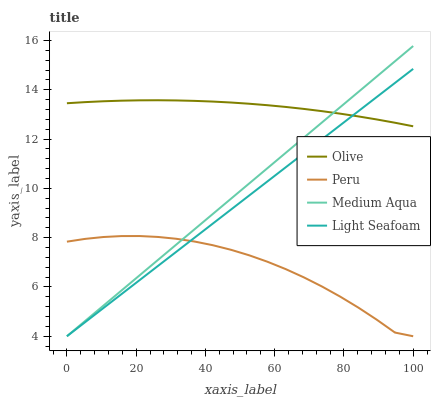Does Peru have the minimum area under the curve?
Answer yes or no. Yes. Does Olive have the maximum area under the curve?
Answer yes or no. Yes. Does Light Seafoam have the minimum area under the curve?
Answer yes or no. No. Does Light Seafoam have the maximum area under the curve?
Answer yes or no. No. Is Medium Aqua the smoothest?
Answer yes or no. Yes. Is Peru the roughest?
Answer yes or no. Yes. Is Light Seafoam the smoothest?
Answer yes or no. No. Is Light Seafoam the roughest?
Answer yes or no. No. Does Light Seafoam have the lowest value?
Answer yes or no. Yes. Does Medium Aqua have the highest value?
Answer yes or no. Yes. Does Light Seafoam have the highest value?
Answer yes or no. No. Is Peru less than Olive?
Answer yes or no. Yes. Is Olive greater than Peru?
Answer yes or no. Yes. Does Light Seafoam intersect Peru?
Answer yes or no. Yes. Is Light Seafoam less than Peru?
Answer yes or no. No. Is Light Seafoam greater than Peru?
Answer yes or no. No. Does Peru intersect Olive?
Answer yes or no. No. 